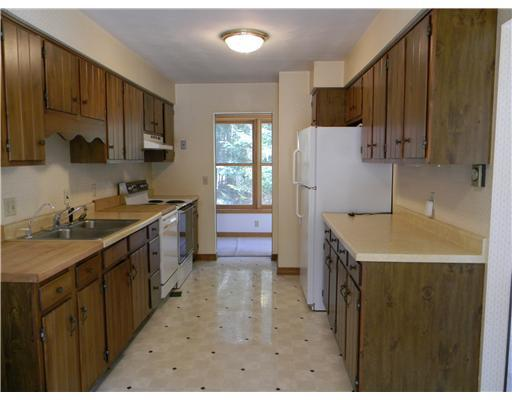How many cooks prepared meals in this kitchen today?

Choices:
A) ten
B) four
C) five
D) none none 